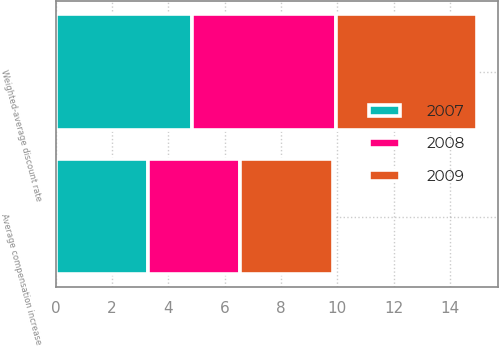<chart> <loc_0><loc_0><loc_500><loc_500><stacked_bar_chart><ecel><fcel>Weighted-average discount rate<fcel>Average compensation increase<nl><fcel>2007<fcel>4.85<fcel>3.27<nl><fcel>2008<fcel>5.09<fcel>3.27<nl><fcel>2009<fcel>5.01<fcel>3.32<nl></chart> 